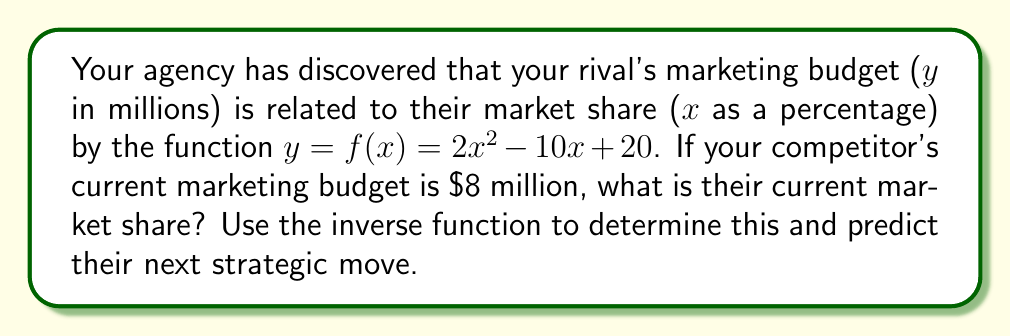What is the answer to this math problem? To solve this problem, we need to find the inverse function of $f(x)$ and then use it to determine the market share given the marketing budget.

1) First, let's find the inverse function:
   Let $y = 2x^2 - 10x + 20$
   Replace $y$ with $x$: $x = 2y^2 - 10y + 20$
   Rearrange to standard form: $2y^2 - 10y + (20-x) = 0$

2) Now we can use the quadratic formula to solve for $y$:
   $y = \frac{-b \pm \sqrt{b^2 - 4ac}}{2a}$

   Where $a=2$, $b=-10$, and $c=(20-x)$

3) Substituting these values:
   $y = \frac{10 \pm \sqrt{100 - 8(20-x)}}{4}$
   $y = \frac{10 \pm \sqrt{100 - 160 + 8x}}{4}$
   $y = \frac{10 \pm \sqrt{8x - 60}}{4}$

4) This is the inverse function. We choose the positive root as market share can't be negative:
   $f^{-1}(x) = \frac{10 + \sqrt{8x - 60}}{4}$

5) Now, we can use this to find the market share when the budget is $8 million:
   $f^{-1}(8) = \frac{10 + \sqrt{8(8) - 60}}{4}$
   $= \frac{10 + \sqrt{64 - 60}}{4}$
   $= \frac{10 + \sqrt{4}}{4}$
   $= \frac{10 + 2}{4}$
   $= \frac{12}{4}$
   $= 3$

6) Therefore, the current market share is 3%.

7) To predict their next strategic move, we can analyze the original function:
   $y = 2x^2 - 10x + 20$
   The coefficient of $x^2$ is positive, so this is a parabola that opens upward.
   The vertex of this parabola represents the minimum marketing budget.
   We can find the vertex using $x = -b/(2a) = -(-10)/(2(2)) = 2.5$

8) This means that the marketing budget is minimized at a market share of 2.5%.
   Since they are currently at 3%, which is to the right of the vertex, 
   their next move might be to increase their market share further, 
   which would require a larger marketing budget according to the function.
Answer: The competitor's current market share is 3%. Their next strategic move is likely to be an attempt to increase their market share beyond 3%, which will require a larger marketing budget. 